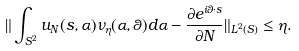<formula> <loc_0><loc_0><loc_500><loc_500>\| \int _ { S ^ { 2 } } u _ { N } ( s , \alpha ) \nu _ { \eta } ( \alpha , \theta ) d \alpha - \frac { \partial e ^ { i \theta \cdot s } } { \partial N } \| _ { L ^ { 2 } ( S ) } \leq \eta .</formula> 